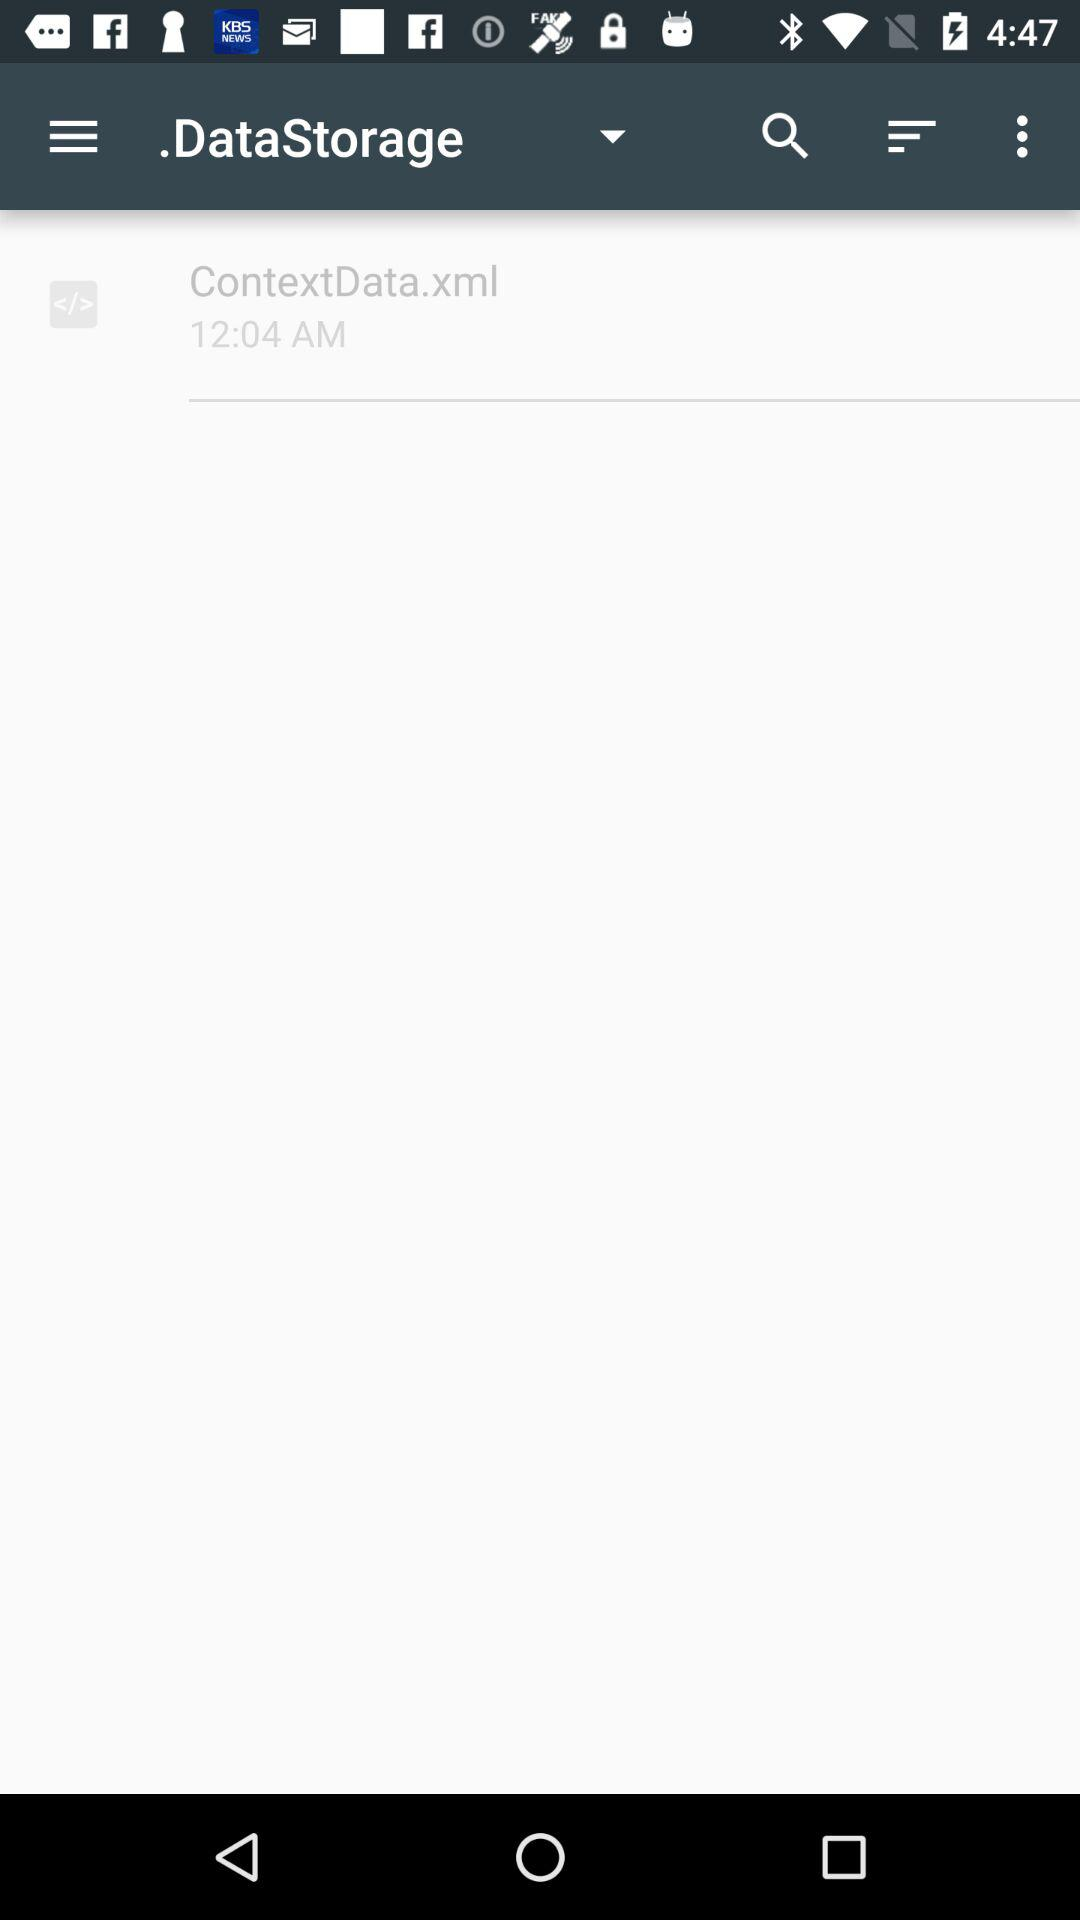What is the time? The time is 12:04 am. 